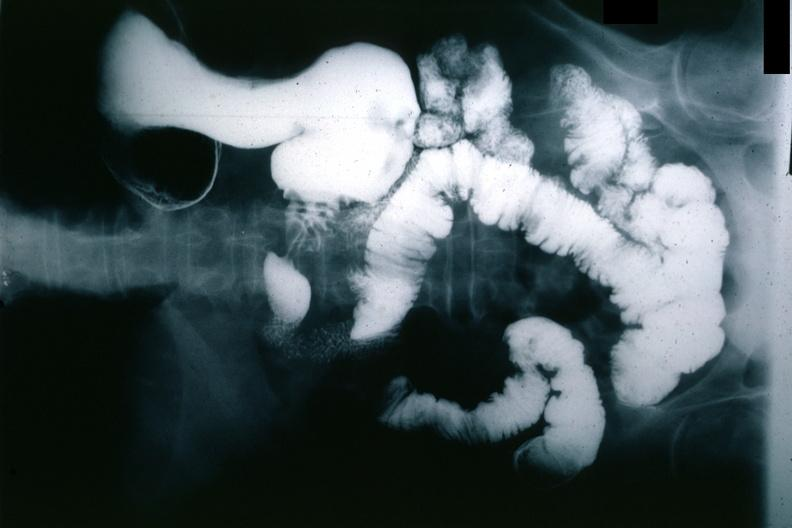s aorta present?
Answer the question using a single word or phrase. No 